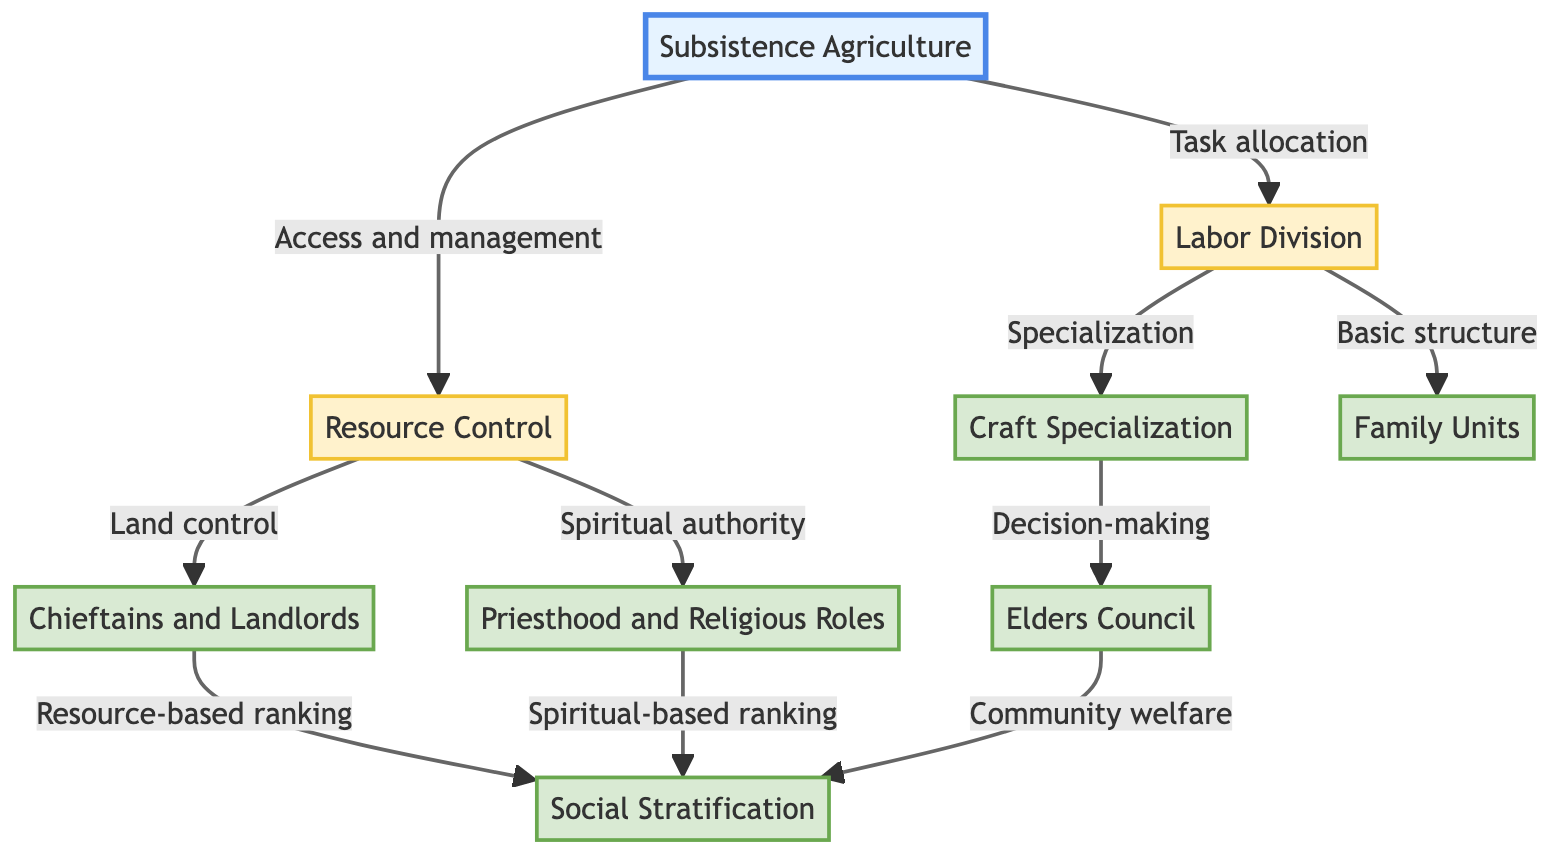What is the title of the flow chart? The title of the flow chart is explicitly stated at the beginning of the diagram as "Social Hierarchies in Pre-Trade Economies".
Answer: Social Hierarchies in Pre-Trade Economies How many main elements are depicted in the flow chart? By counting the number of distinct elements listed, there are a total of 9 main elements in the flow chart.
Answer: 9 Which element is the starting point of the flow chart? The flow chart begins with "Subsistence Agriculture", which has arrows pointing to two subsequent elements, indicating it as the starting point.
Answer: Subsistence Agriculture What are the two connections from "Resource Control"? The two connections from "Resource Control" lead to "Chieftains and Landlords" and "Priesthood and Religious Roles", indicating the two roles derived from managing resources.
Answer: Chieftains and Landlords, Priesthood and Religious Roles Which element is responsible for decision-making regarding community welfare? "Elders Council" is shown as the element that is involved in decision-making for community welfare, with connections leading to "Social Stratification".
Answer: Elders Council What leads to "Social Stratification"? The elements "Chieftains and Landlords" and "Priesthood and Religious Roles" both contribute to "Social Stratification", as they establish a ranking based on resource control and spiritual authority, respectively.
Answer: Chieftains and Landlords, Priesthood and Religious Roles What role does "Craft Specialization" play in the flow chart? "Craft Specialization" is connected to "Elders Council" for decision-making, indicating that it plays a role in the community's production activities and thus affects community governance.
Answer: Decision-making Which two elements represent the basic structure of production and reproduction? The "Family Units" and "Labor Division" represent the basic structure for production and reproduction in the community, with connections indicating their contributions to subsistence practices.
Answer: Family Units, Labor Division What type of roles define the spiritual authority in the flow chart? The flow chart identifies "Priesthood and Religious Roles" as the specific element that defines spiritual authority within the social hierarchy.
Answer: Priesthood and Religious Roles 